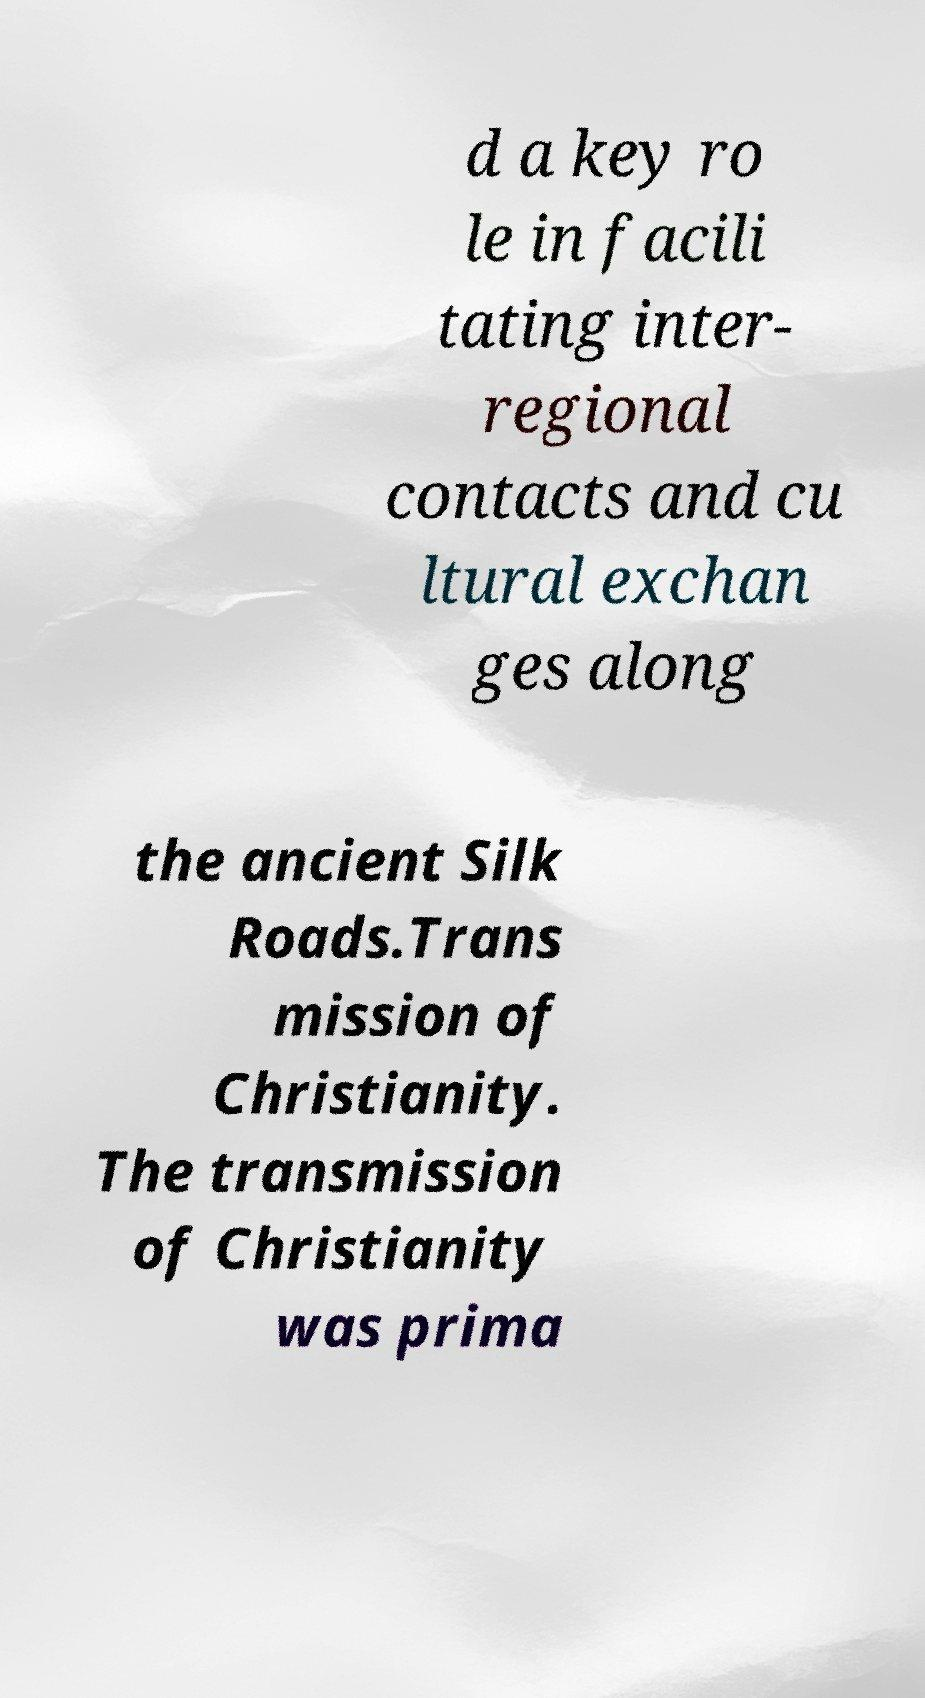Could you assist in decoding the text presented in this image and type it out clearly? d a key ro le in facili tating inter- regional contacts and cu ltural exchan ges along the ancient Silk Roads.Trans mission of Christianity. The transmission of Christianity was prima 